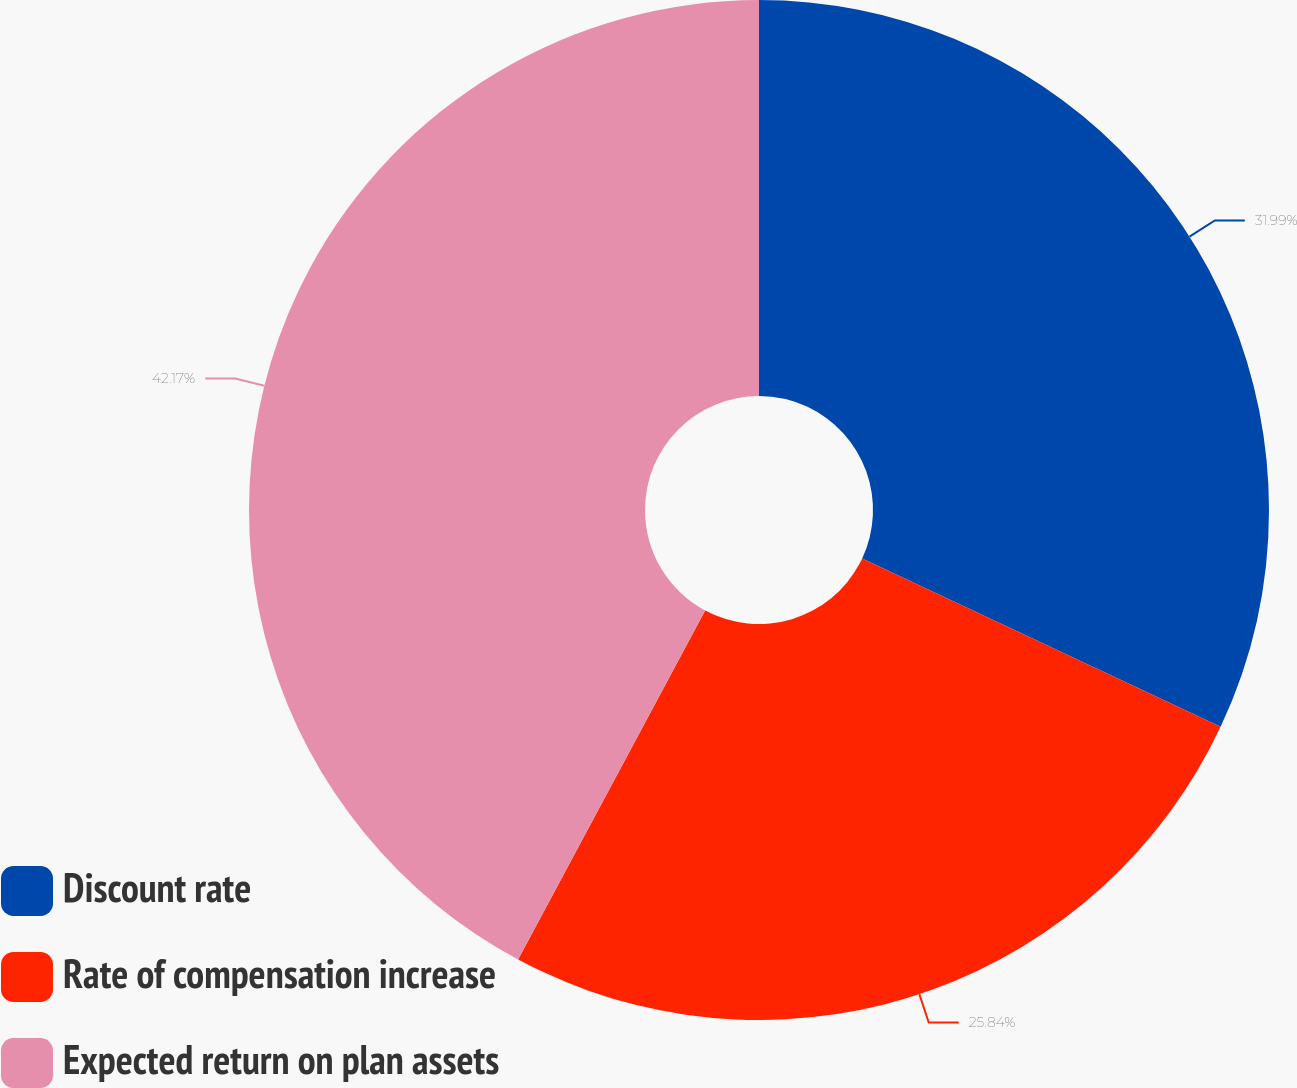<chart> <loc_0><loc_0><loc_500><loc_500><pie_chart><fcel>Discount rate<fcel>Rate of compensation increase<fcel>Expected return on plan assets<nl><fcel>31.99%<fcel>25.84%<fcel>42.17%<nl></chart> 